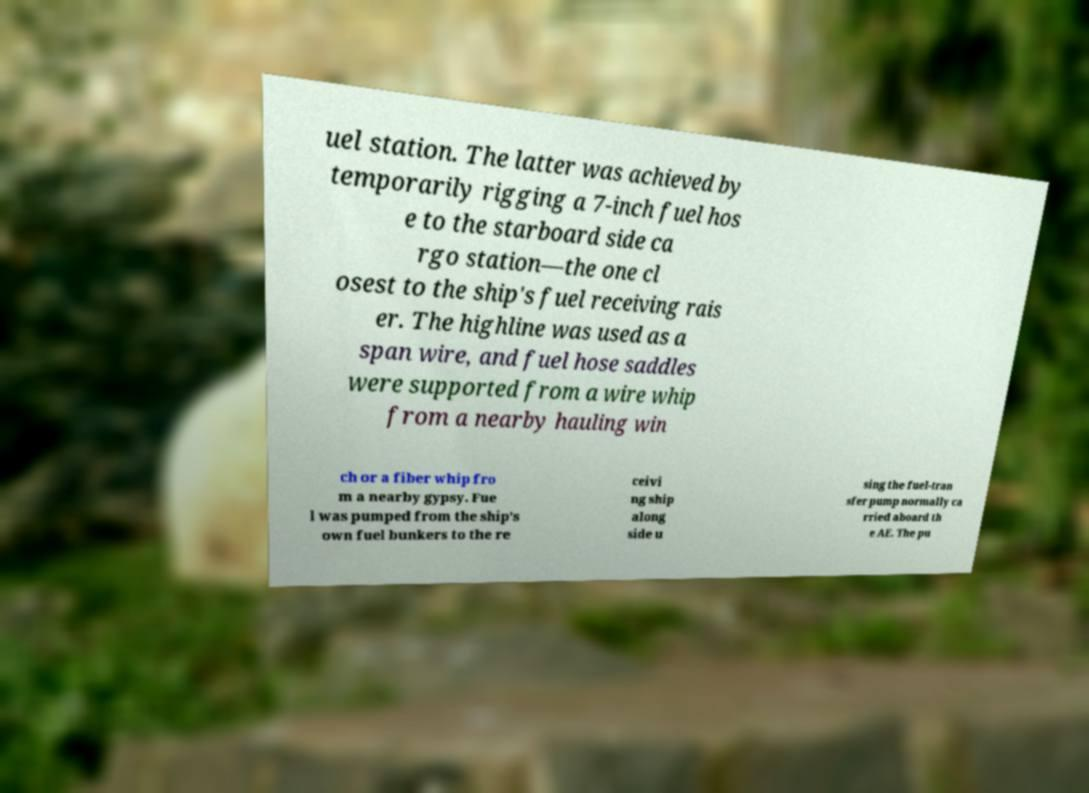Please identify and transcribe the text found in this image. uel station. The latter was achieved by temporarily rigging a 7-inch fuel hos e to the starboard side ca rgo station—the one cl osest to the ship's fuel receiving rais er. The highline was used as a span wire, and fuel hose saddles were supported from a wire whip from a nearby hauling win ch or a fiber whip fro m a nearby gypsy. Fue l was pumped from the ship's own fuel bunkers to the re ceivi ng ship along side u sing the fuel-tran sfer pump normally ca rried aboard th e AE. The pu 